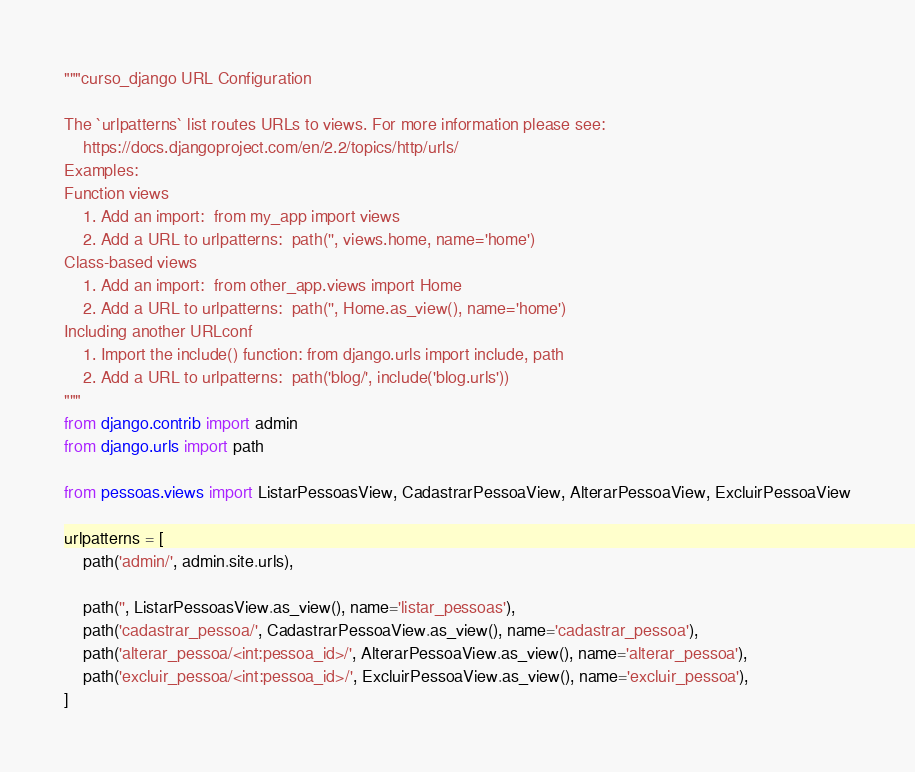Convert code to text. <code><loc_0><loc_0><loc_500><loc_500><_Python_>"""curso_django URL Configuration

The `urlpatterns` list routes URLs to views. For more information please see:
    https://docs.djangoproject.com/en/2.2/topics/http/urls/
Examples:
Function views
    1. Add an import:  from my_app import views
    2. Add a URL to urlpatterns:  path('', views.home, name='home')
Class-based views
    1. Add an import:  from other_app.views import Home
    2. Add a URL to urlpatterns:  path('', Home.as_view(), name='home')
Including another URLconf
    1. Import the include() function: from django.urls import include, path
    2. Add a URL to urlpatterns:  path('blog/', include('blog.urls'))
"""
from django.contrib import admin
from django.urls import path

from pessoas.views import ListarPessoasView, CadastrarPessoaView, AlterarPessoaView, ExcluirPessoaView

urlpatterns = [
    path('admin/', admin.site.urls),

    path('', ListarPessoasView.as_view(), name='listar_pessoas'),
    path('cadastrar_pessoa/', CadastrarPessoaView.as_view(), name='cadastrar_pessoa'),
    path('alterar_pessoa/<int:pessoa_id>/', AlterarPessoaView.as_view(), name='alterar_pessoa'),
    path('excluir_pessoa/<int:pessoa_id>/', ExcluirPessoaView.as_view(), name='excluir_pessoa'),
]
</code> 